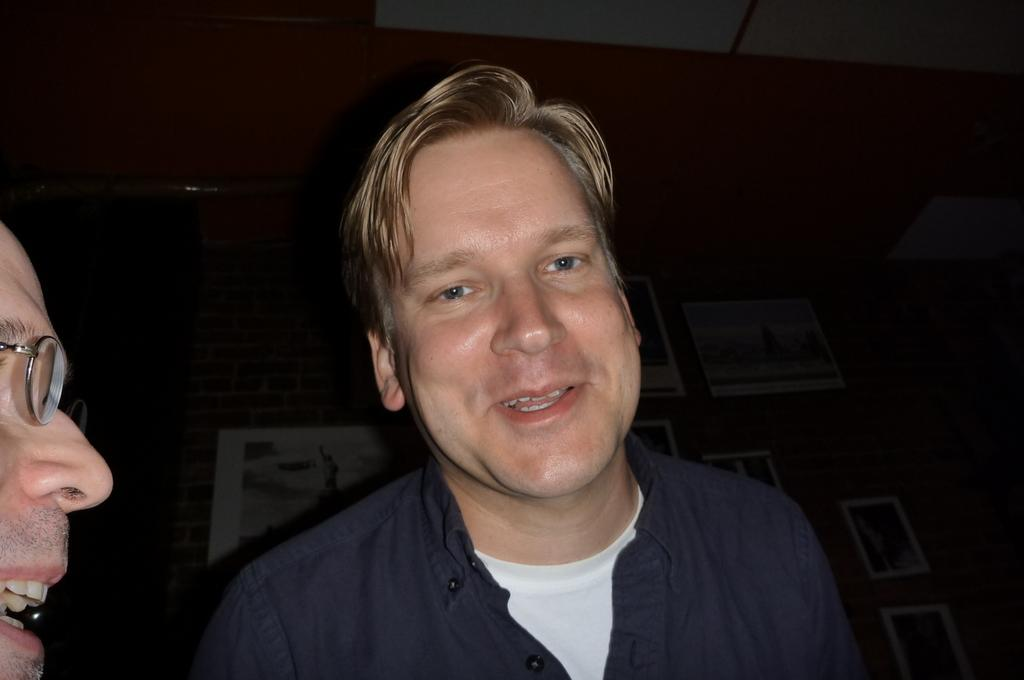How many people are present in the image? There are two people in the image. What can be seen on the wall in the image? There is a wall with picture frames in the image. What type of shoes are the crooks wearing in the image? There is no mention of crooks or shoes in the image, so we cannot answer that question. 